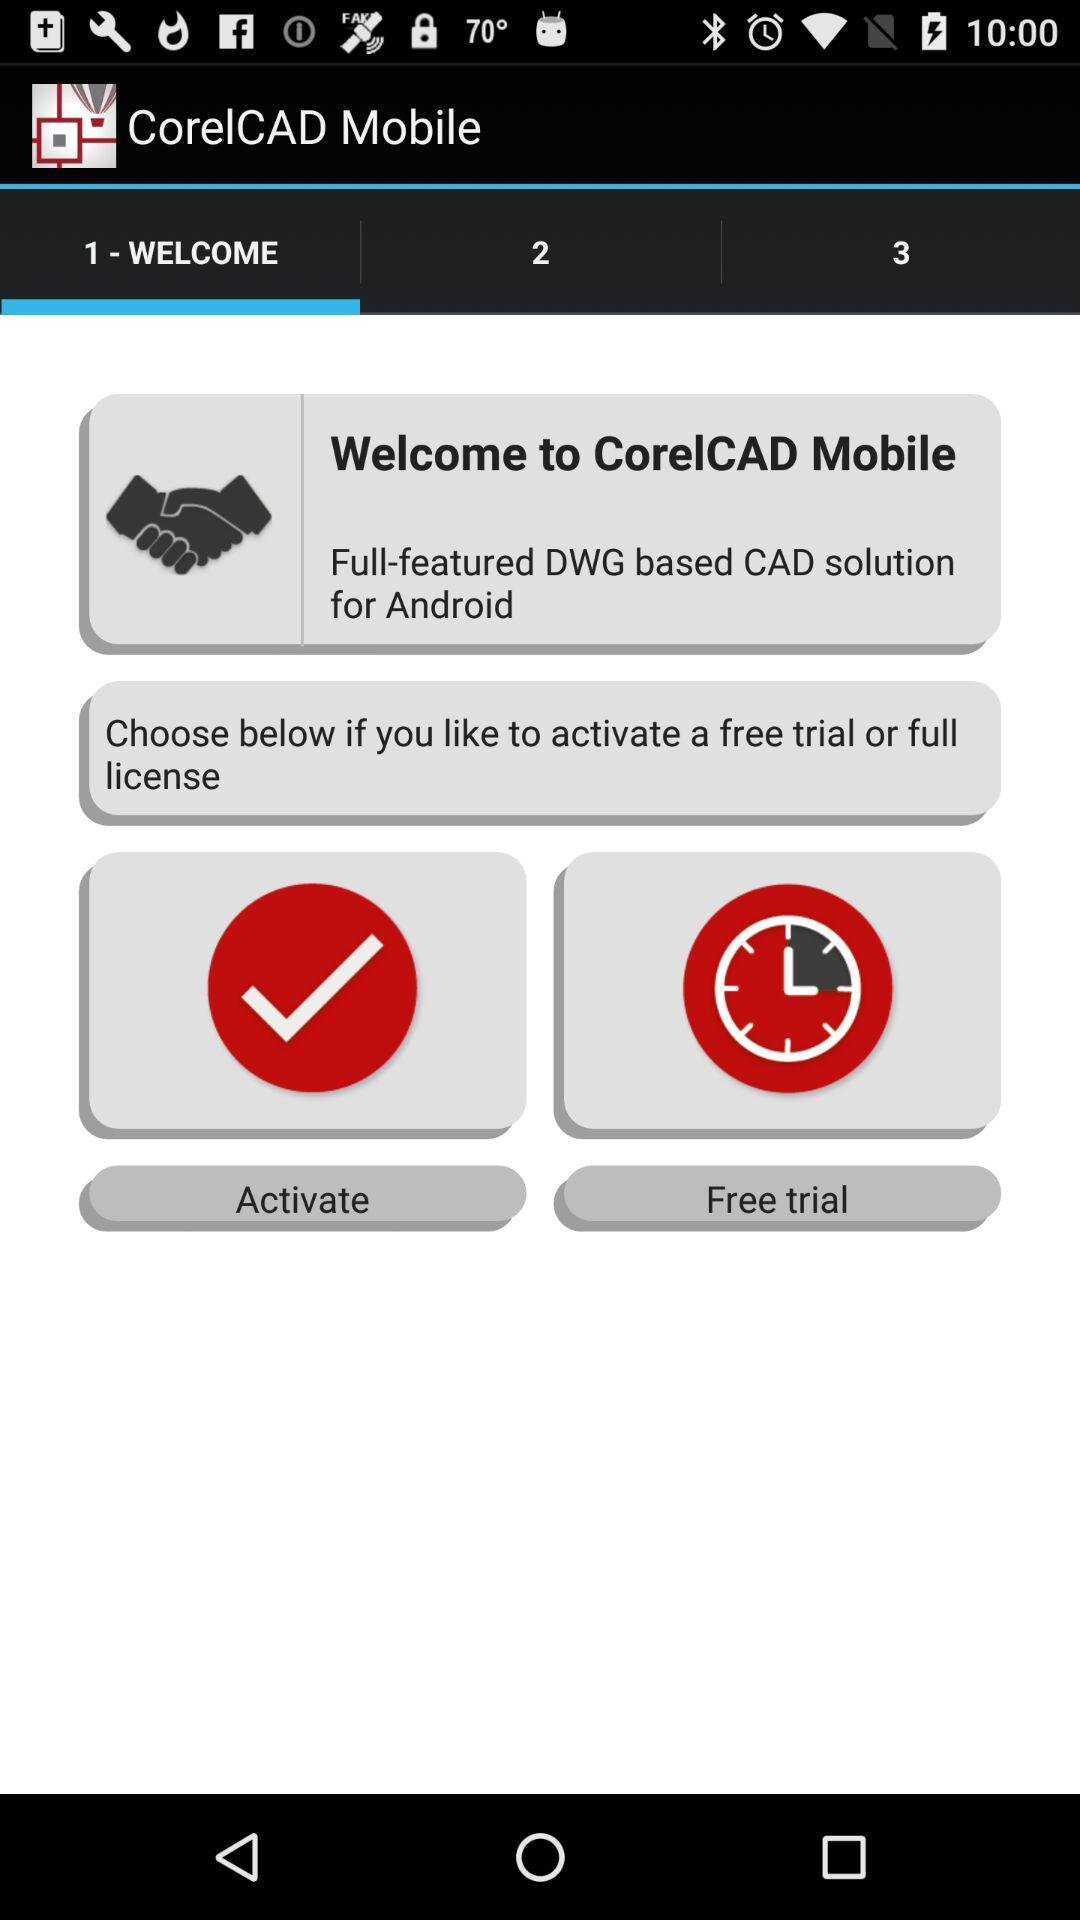Which tab is selected? The selected tab is "1 - WELCOME". 